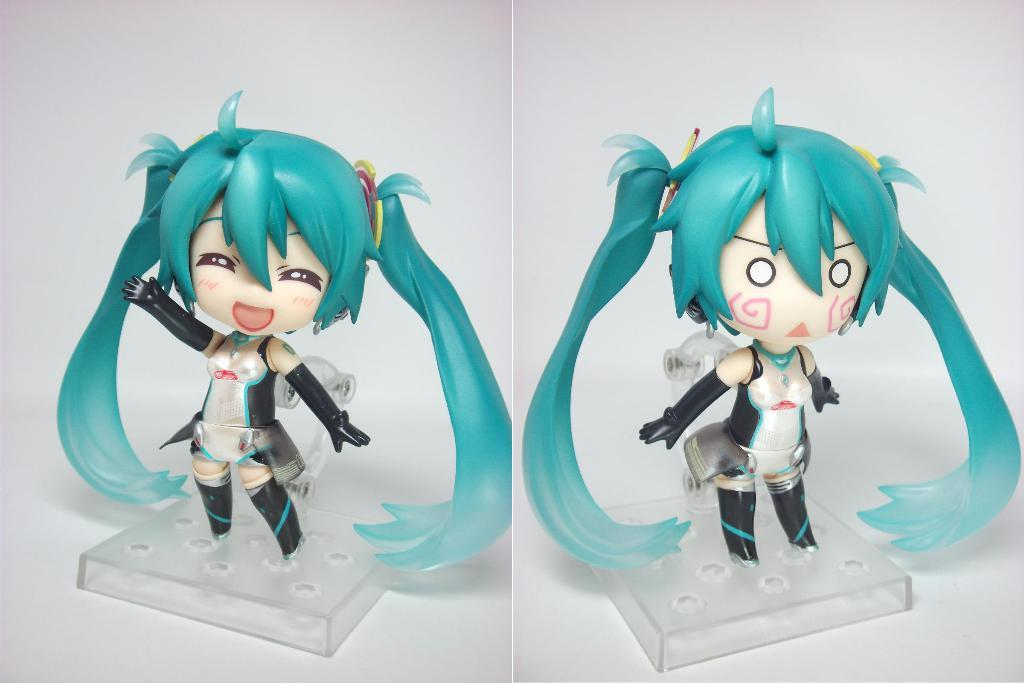What type of artwork is depicted in the image? The image is a collage. What objects are included in the collage? There are toys in the collage. How are the toys arranged in the image? The toys are placed in a box. What type of sleet can be seen falling on the toys in the image? There is no sleet present in the image; it is a collage of toys placed in a box. How many cattle are visible in the image? There are no cattle present in the image; it features a collage of toys placed in a box. 